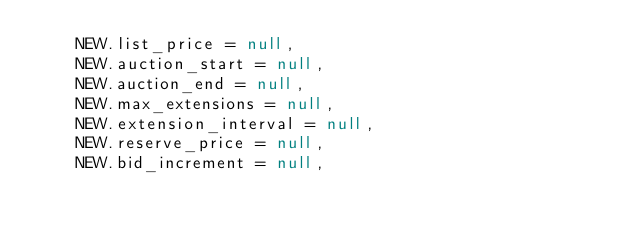Convert code to text. <code><loc_0><loc_0><loc_500><loc_500><_SQL_>    NEW.list_price = null,
    NEW.auction_start = null,
    NEW.auction_end = null,
    NEW.max_extensions = null,
    NEW.extension_interval = null,
    NEW.reserve_price = null,
    NEW.bid_increment = null,</code> 